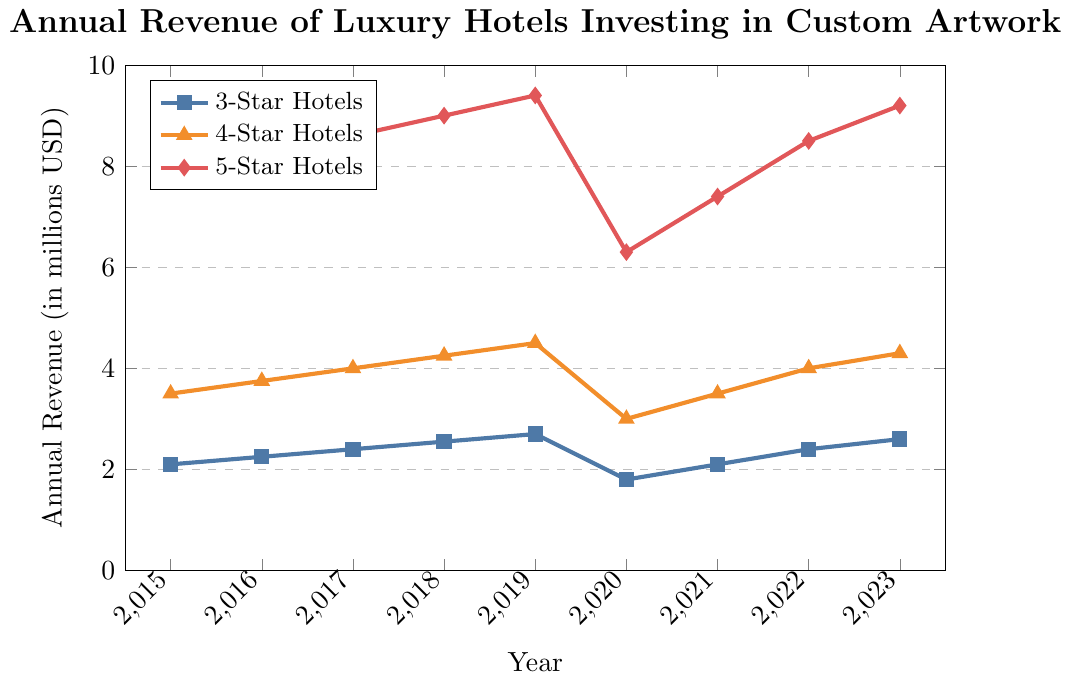What was the revenue for 5-Star hotels in 2020? Look at the data point for 5-Star hotels in the year 2020. The mark on the plot shows approximately 6.3 million USD.
Answer: 6.3 million USD Which hotel star rating had the highest revenue in 2022? Compare the data points for 3-Star, 4-Star, and 5-Star hotels in the year 2022. 5-Star hotels had the highest revenue at approximately 8.5 million USD.
Answer: 5-Star hotels How much did the revenue for 3-Star hotels increase from 2015 to 2023? Subtract the revenue for 3-Star hotels in 2015 from the revenue in 2023. (2.6 - 2.1) million USD = 0.5 million USD.
Answer: 0.5 million USD Which year saw a significant drop in revenue for all hotel star ratings? Observe the trend lines for all hotel star ratings; all lines show a significant drop between 2019 and 2020.
Answer: 2020 By how much did the revenue for 4-Star hotels change between 2019 and 2020? Subtract the revenue for 4-Star hotels in 2020 from the revenue in 2019. (4.5 - 3.0) million USD = 1.5 million USD.
Answer: 1.5 million USD What is the trend in revenue for 5-Star hotels from 2015 to 2023? Observe the data points for 5-Star hotels from 2015 to 2023. The trend shows a steady increase with a dip in 2020, then recovering again in the following years.
Answer: Steady increase with a dip in 2020 How does the revenue change for 4-Star hotels from 2018 to 2021? Identify the revenue for 4-Star hotels in 2018 and observe the change until 2021. The revenue increased from 4.25 million USD in 2018 to 3.5 million USD in 2021, indicating a drop in 2020 but recovery afterward.
Answer: Drop in 2020 and recovery afterward Did 3-Star hotels ever surpass the 2.7 million USD revenue mark between 2015 and 2023? Examine the data points for 3-Star hotels from 2015 to 2023. The highest revenue point is 2.7 million USD in 2019, which they did not surpass at any other point in time.
Answer: No 